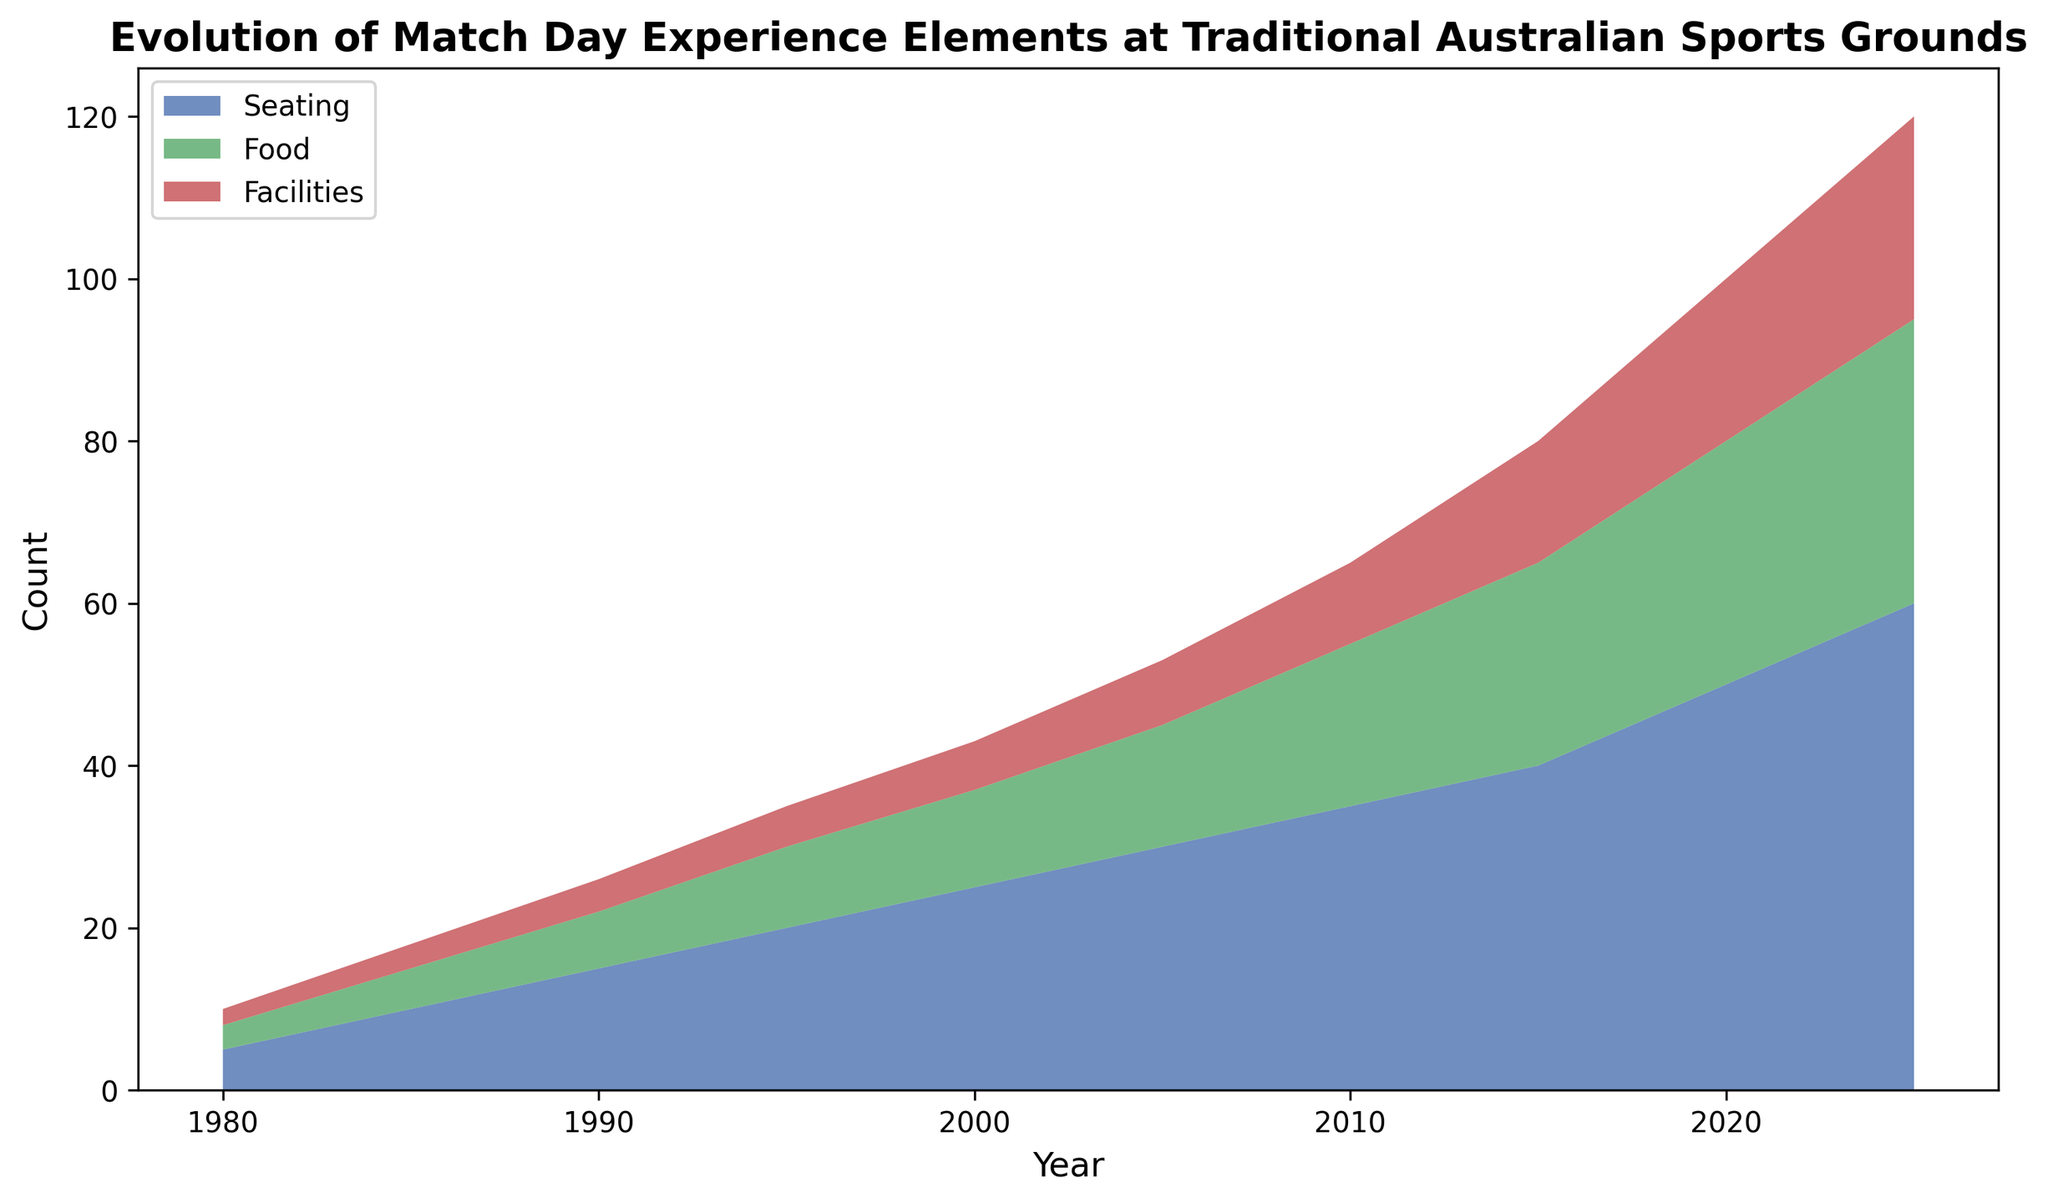What trend can we observe in the seating element from 1980 to 2025? The seating element continuously increases from 5 in 1980 to 60 in 2025. This represents a steady upward trend in the number of seating elements provided over the years.
Answer: The seating element shows a continuously increasing trend In which year do food and facilities combined surpass the value of seating? To answer this, we need to find the point where the combined value (food + facilities) exceeds seating. In 2025, food (35) + facilities (25) = 60, which matches the seating value (60). Prior to this, the combined value is less than seating.
Answer: 2025 Between which years does the food element experience the highest rate of increase? We need to calculate the increments between consecutive years. The largest increase for food is from 2010 (20) to 2015 (25), which is 5 units.
Answer: Between 2010 and 2015 Which element starts off with the least value in 1980? Looking at the data for 1980, seating is 5, food is 3, and facilities are 2. The element with the smallest value is facilities.
Answer: Facilities What is the average annual increase in the facilities element between 1980 and 2025? The total increase in facilities from 1980 (2) to 2025 (25) is 23 units over 45 years. The average annual increase is 23/45.
Answer: 0.51 units/year How do the elements compare visually in terms of area covered by different colors? The colors represent different elements: one color for seating, another for food, and another for facilities. The color representing seating covers the largest area, followed by food, then facilities.
Answer: Seating covers the largest area By how much does the seating element increase from 2000 to 2010? Seating in 2000 is 25 and in 2010 is 35. The increase is 35 - 25.
Answer: 10 units Which element shows the most steady increase visually over the entire period? Visually, all elements increase, but the slope of seating appears more consistent without fluctuations when compared to food and facilities.
Answer: Seating Is there any year where all three elements have the same value? By examining the figure, no single vertical point demonstrates equal values for all three elements simultaneously.
Answer: No 